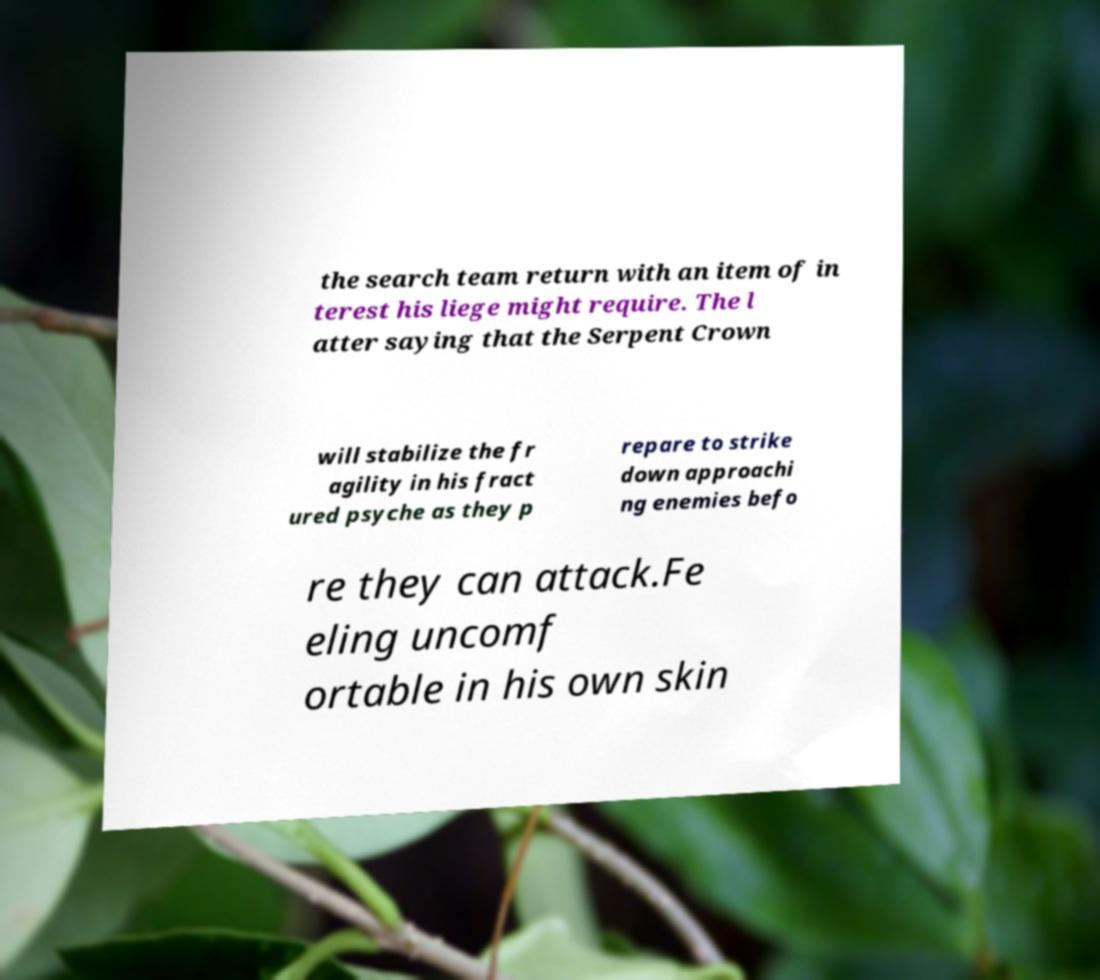Please identify and transcribe the text found in this image. the search team return with an item of in terest his liege might require. The l atter saying that the Serpent Crown will stabilize the fr agility in his fract ured psyche as they p repare to strike down approachi ng enemies befo re they can attack.Fe eling uncomf ortable in his own skin 